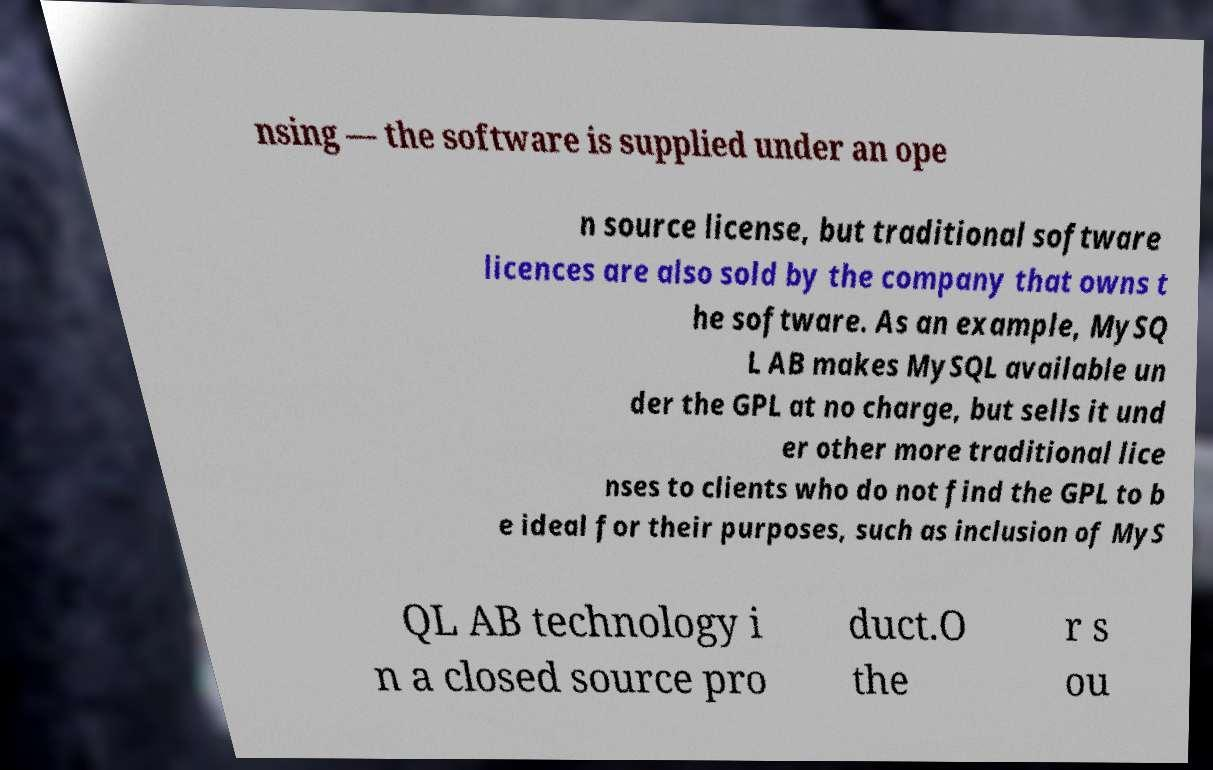For documentation purposes, I need the text within this image transcribed. Could you provide that? nsing — the software is supplied under an ope n source license, but traditional software licences are also sold by the company that owns t he software. As an example, MySQ L AB makes MySQL available un der the GPL at no charge, but sells it und er other more traditional lice nses to clients who do not find the GPL to b e ideal for their purposes, such as inclusion of MyS QL AB technology i n a closed source pro duct.O the r s ou 